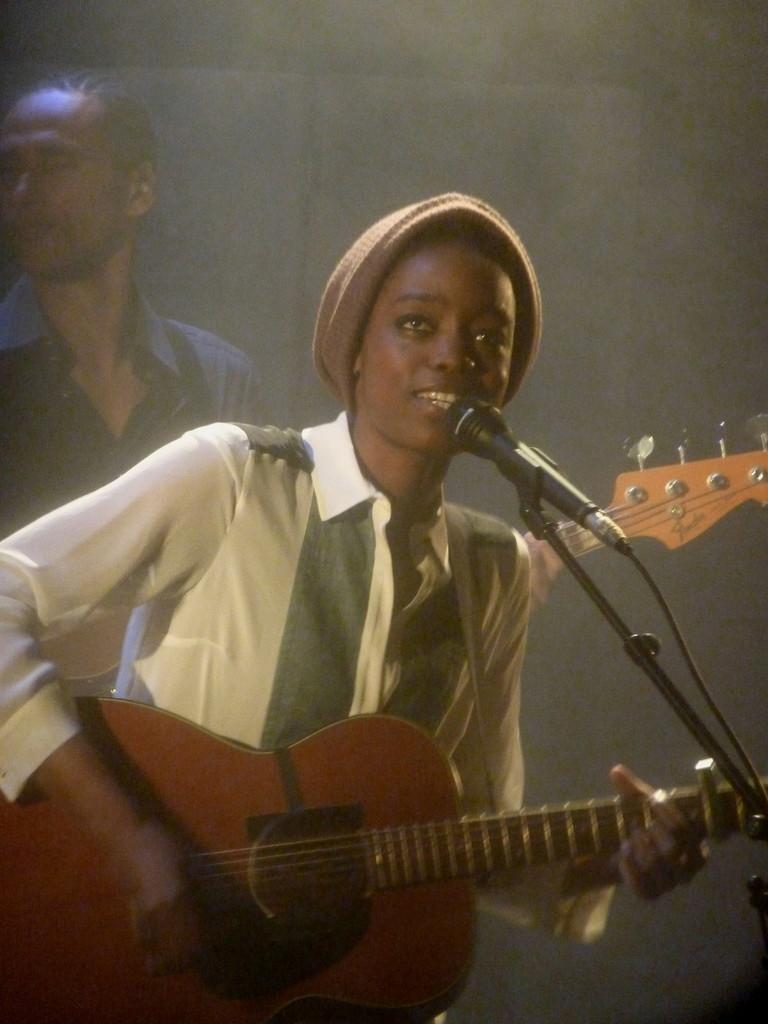Who is the main subject in the image? There is a woman in the image. What is the woman doing in the image? The woman is singing and playing a guitar. Can you describe the background of the image? There is a man standing in the background of the image. What type of crib is visible in the image? There is no crib present in the image. 